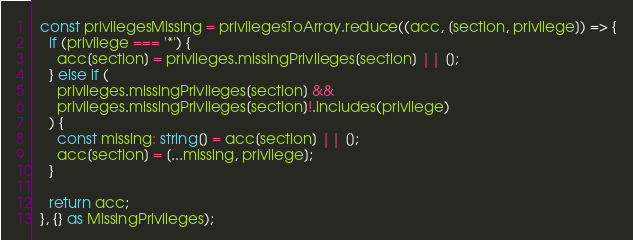<code> <loc_0><loc_0><loc_500><loc_500><_TypeScript_>  const privilegesMissing = privilegesToArray.reduce((acc, [section, privilege]) => {
    if (privilege === '*') {
      acc[section] = privileges.missingPrivileges[section] || [];
    } else if (
      privileges.missingPrivileges[section] &&
      privileges.missingPrivileges[section]!.includes(privilege)
    ) {
      const missing: string[] = acc[section] || [];
      acc[section] = [...missing, privilege];
    }

    return acc;
  }, {} as MissingPrivileges);
</code> 